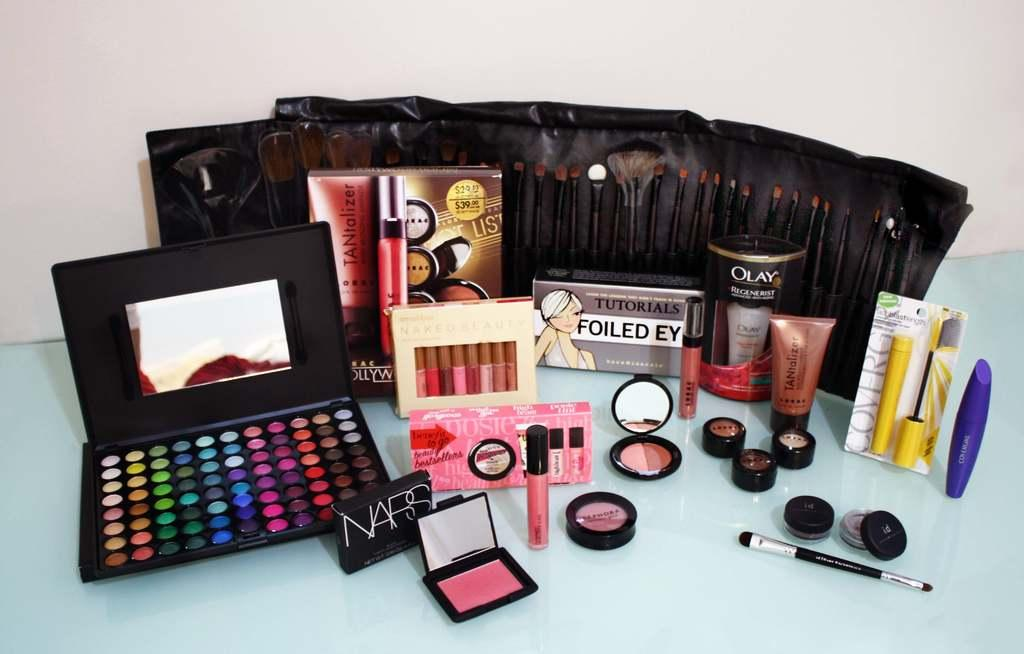<image>
Create a compact narrative representing the image presented. A makeup kid displaying products such as Olay 